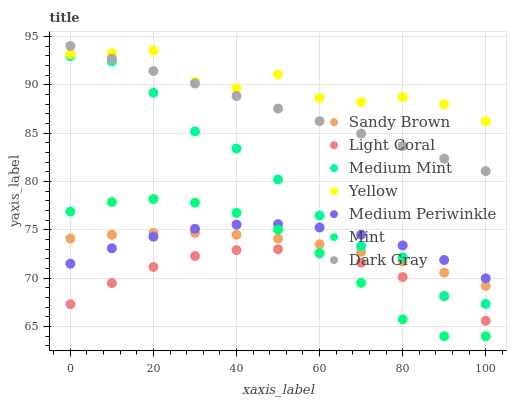Does Light Coral have the minimum area under the curve?
Answer yes or no. Yes. Does Yellow have the maximum area under the curve?
Answer yes or no. Yes. Does Dark Gray have the minimum area under the curve?
Answer yes or no. No. Does Dark Gray have the maximum area under the curve?
Answer yes or no. No. Is Dark Gray the smoothest?
Answer yes or no. Yes. Is Yellow the roughest?
Answer yes or no. Yes. Is Mint the smoothest?
Answer yes or no. No. Is Mint the roughest?
Answer yes or no. No. Does Mint have the lowest value?
Answer yes or no. Yes. Does Dark Gray have the lowest value?
Answer yes or no. No. Does Dark Gray have the highest value?
Answer yes or no. Yes. Does Mint have the highest value?
Answer yes or no. No. Is Sandy Brown less than Yellow?
Answer yes or no. Yes. Is Yellow greater than Medium Mint?
Answer yes or no. Yes. Does Sandy Brown intersect Medium Periwinkle?
Answer yes or no. Yes. Is Sandy Brown less than Medium Periwinkle?
Answer yes or no. No. Is Sandy Brown greater than Medium Periwinkle?
Answer yes or no. No. Does Sandy Brown intersect Yellow?
Answer yes or no. No. 